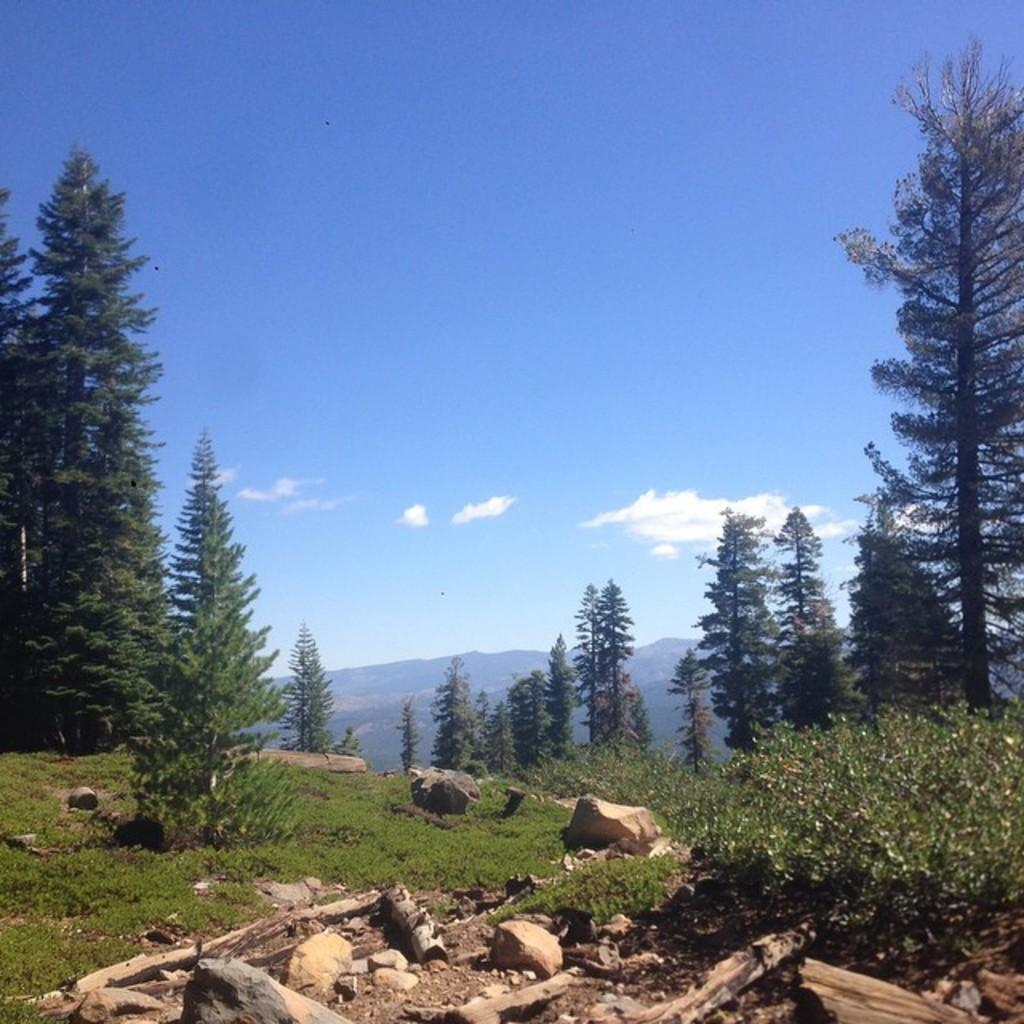What type of vegetation can be seen in the image? There are plants, grass, and trees in the image. What other natural elements are present in the image? There are rocks in the image. What can be seen in the background of the image? The sky is visible in the background of the image, and there are clouds in the sky. What type of vessel is being used to water the plants in the image? There is no vessel present in the image, and no watering is taking place. 